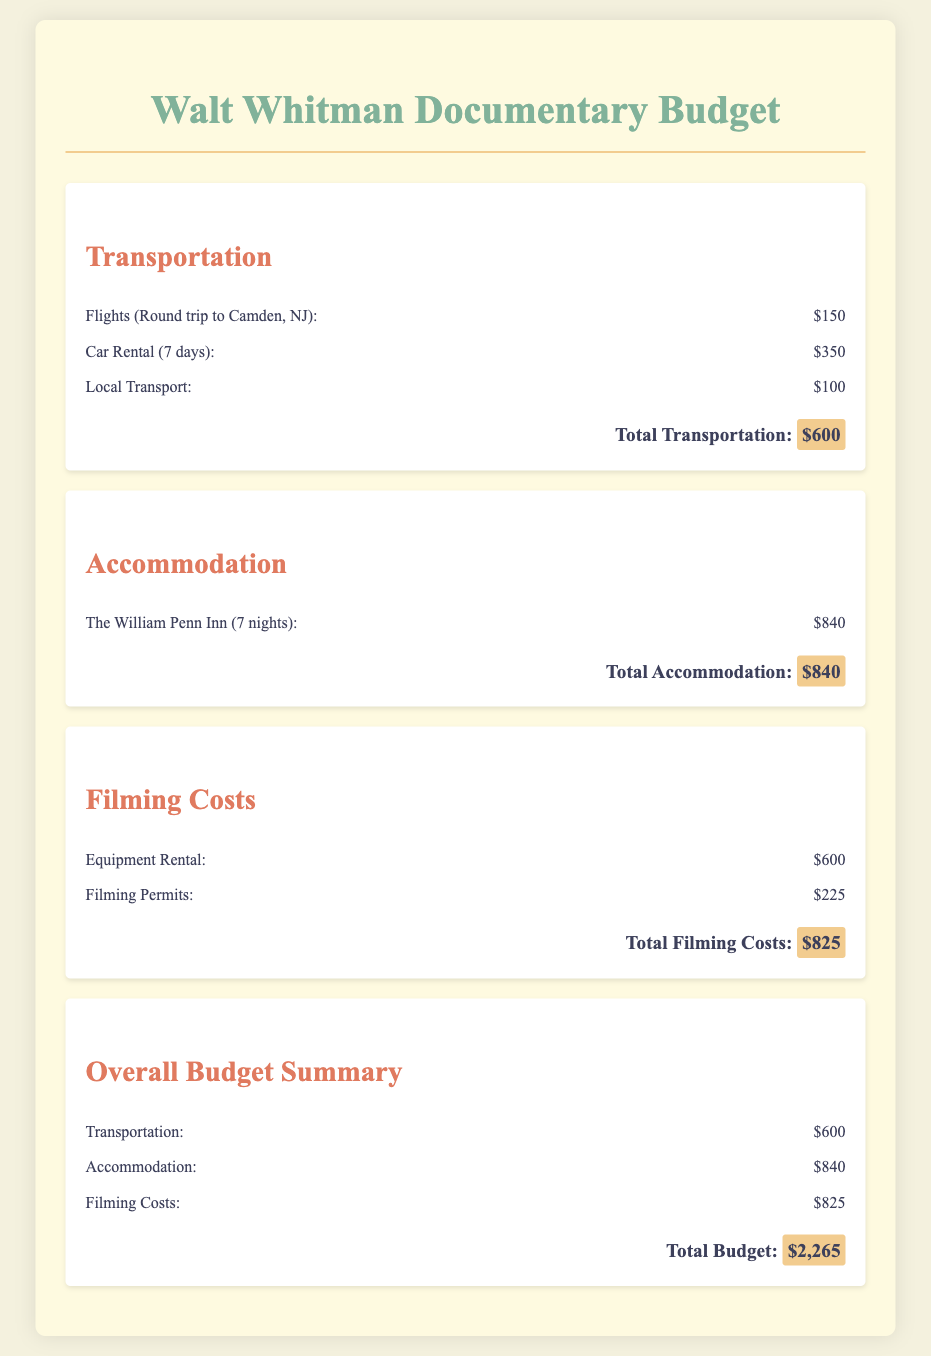What is the total transportation cost? The total transportation cost is listed under the Transportation section, which sums the flights, car rental, and local transport costs.
Answer: $600 What is the accommodation cost at The William Penn Inn for 7 nights? The accommodation cost for 7 nights at The William Penn Inn is detailed in the Accommodation section.
Answer: $840 What are the filming permit costs? The filming permit costs are provided in the Filming Costs section, listing the expense for permits.
Answer: $225 What is the total budget for the documentary? The total budget is the sum of transportation, accommodation, and filming costs, calculated in the Overall Budget Summary section.
Answer: $2,265 How much is the equipment rental for filming? The equipment rental cost is specified under Filming Costs, indicating the total rent for equipment used in filming.
Answer: $600 What expense category has the highest cost? The Overall Budget Summary presents all categories, and the category with the highest cost is determined by comparing the total amounts.
Answer: Accommodation 